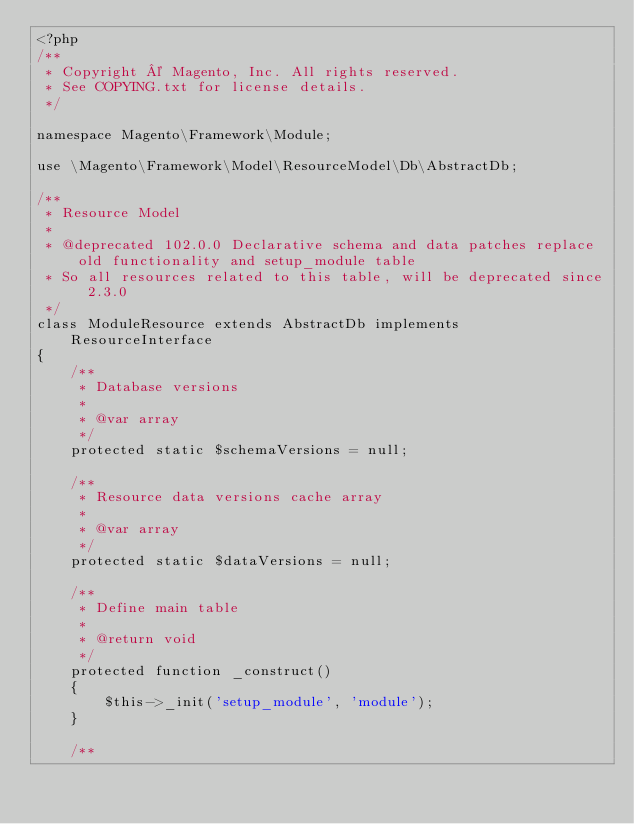Convert code to text. <code><loc_0><loc_0><loc_500><loc_500><_PHP_><?php
/**
 * Copyright © Magento, Inc. All rights reserved.
 * See COPYING.txt for license details.
 */

namespace Magento\Framework\Module;

use \Magento\Framework\Model\ResourceModel\Db\AbstractDb;

/**
 * Resource Model
 *
 * @deprecated 102.0.0 Declarative schema and data patches replace old functionality and setup_module table
 * So all resources related to this table, will be deprecated since 2.3.0
 */
class ModuleResource extends AbstractDb implements ResourceInterface
{
    /**
     * Database versions
     *
     * @var array
     */
    protected static $schemaVersions = null;

    /**
     * Resource data versions cache array
     *
     * @var array
     */
    protected static $dataVersions = null;

    /**
     * Define main table
     *
     * @return void
     */
    protected function _construct()
    {
        $this->_init('setup_module', 'module');
    }

    /**</code> 